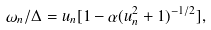Convert formula to latex. <formula><loc_0><loc_0><loc_500><loc_500>\omega _ { n } / \Delta = u _ { n } [ 1 - \alpha ( u _ { n } ^ { 2 } + 1 ) ^ { - 1 / 2 } ] ,</formula> 